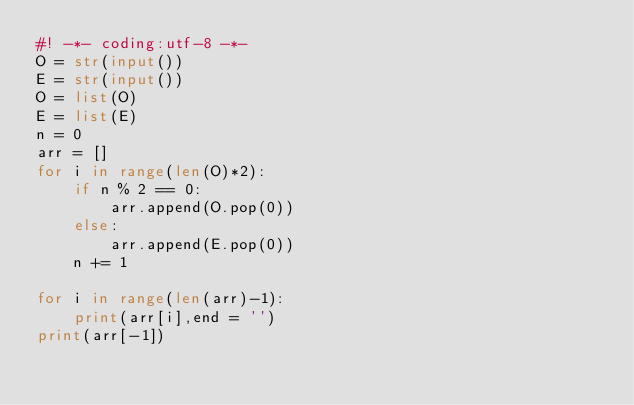Convert code to text. <code><loc_0><loc_0><loc_500><loc_500><_Python_>#! -*- coding:utf-8 -*-
O = str(input())
E = str(input())
O = list(O)
E = list(E)
n = 0
arr = []
for i in range(len(O)*2):
    if n % 2 == 0:
        arr.append(O.pop(0))
    else:
        arr.append(E.pop(0))
    n += 1
    
for i in range(len(arr)-1):
    print(arr[i],end = '')
print(arr[-1])
</code> 